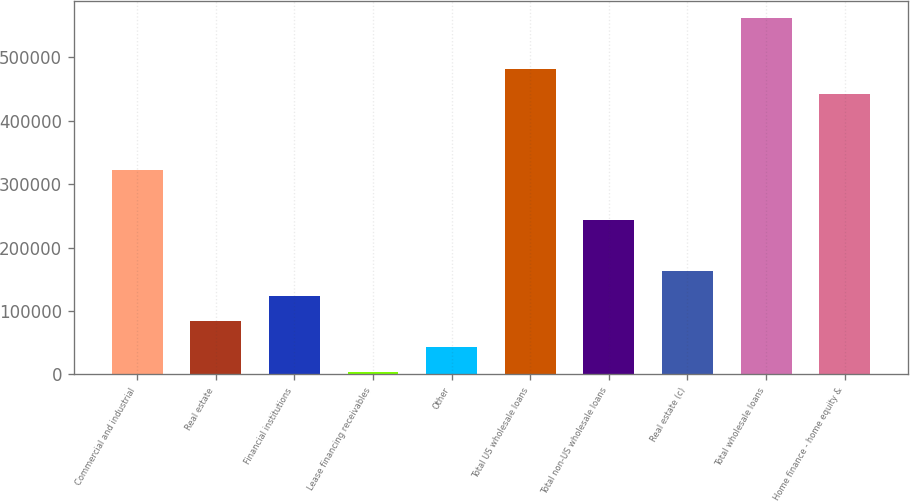Convert chart to OTSL. <chart><loc_0><loc_0><loc_500><loc_500><bar_chart><fcel>Commercial and industrial<fcel>Real estate<fcel>Financial institutions<fcel>Lease financing receivables<fcel>Other<fcel>Total US wholesale loans<fcel>Total non-US wholesale loans<fcel>Real estate (c)<fcel>Total wholesale loans<fcel>Home finance - home equity &<nl><fcel>322500<fcel>83657.2<fcel>123464<fcel>4043<fcel>43850.1<fcel>481728<fcel>242886<fcel>163271<fcel>561342<fcel>441921<nl></chart> 